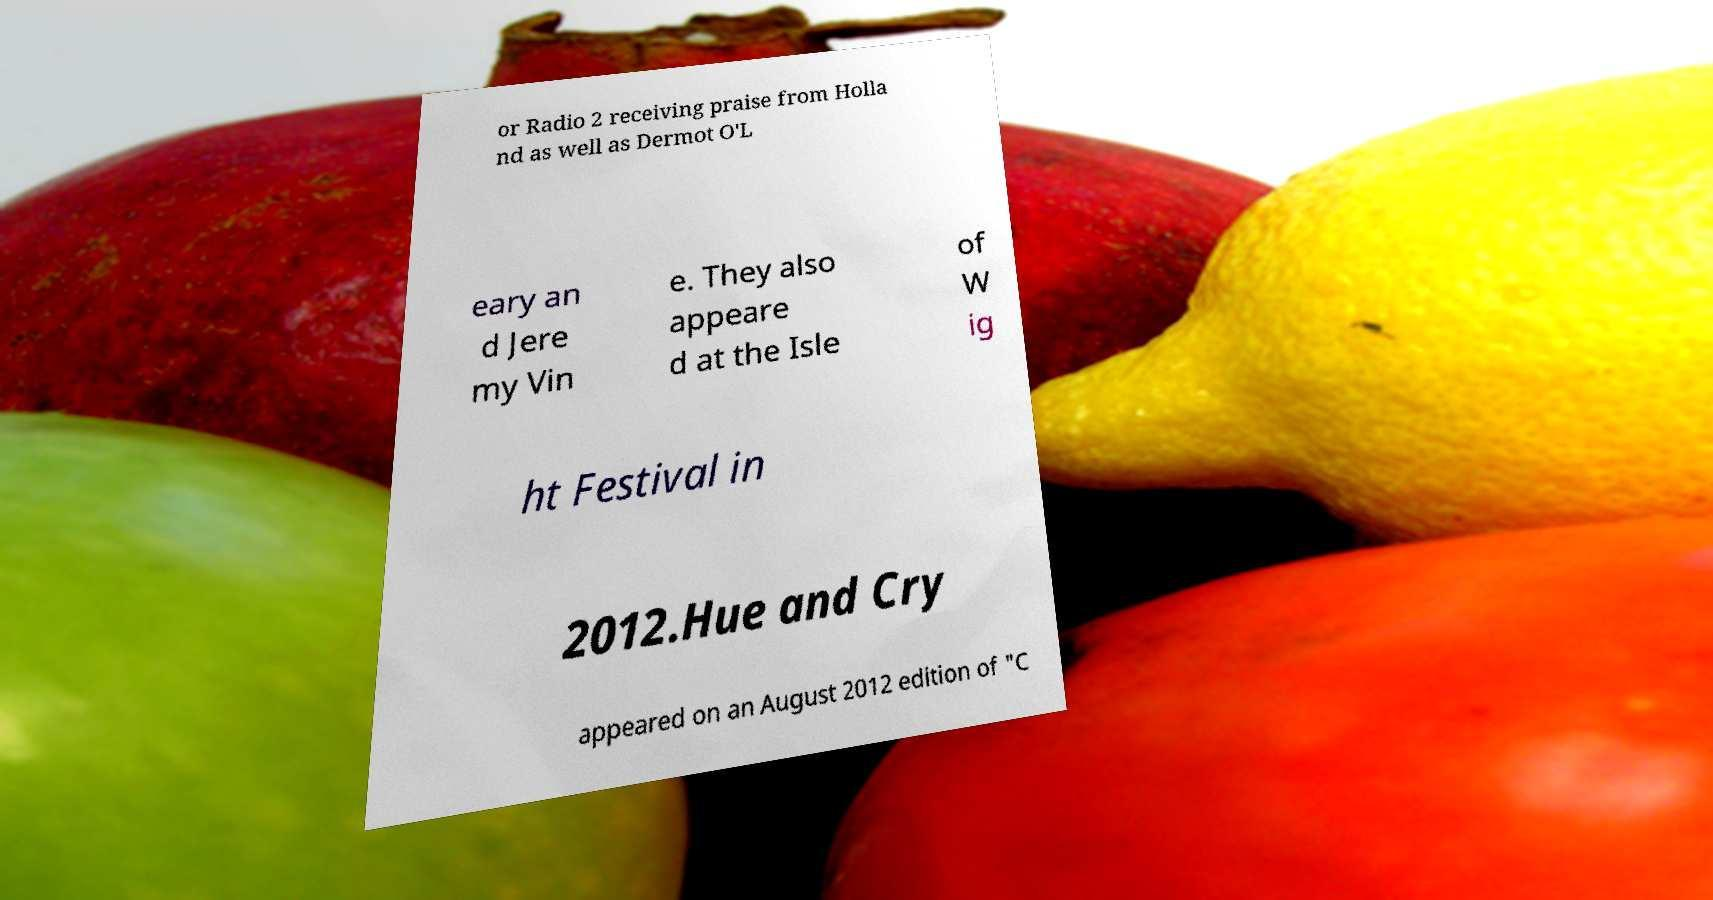Please read and relay the text visible in this image. What does it say? or Radio 2 receiving praise from Holla nd as well as Dermot O'L eary an d Jere my Vin e. They also appeare d at the Isle of W ig ht Festival in 2012.Hue and Cry appeared on an August 2012 edition of "C 